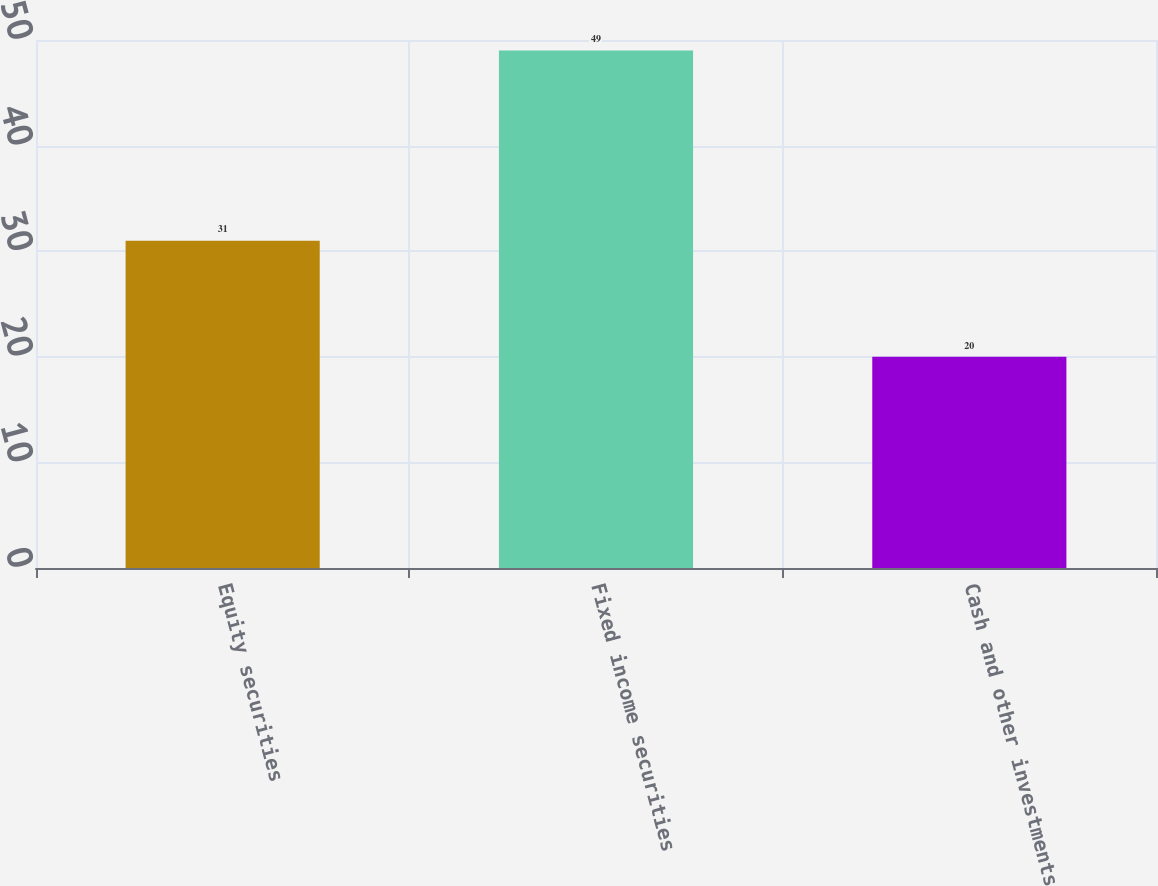Convert chart to OTSL. <chart><loc_0><loc_0><loc_500><loc_500><bar_chart><fcel>Equity securities<fcel>Fixed income securities<fcel>Cash and other investments<nl><fcel>31<fcel>49<fcel>20<nl></chart> 